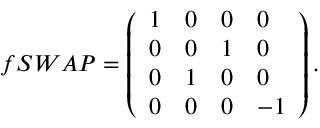Convert formula to latex. <formula><loc_0><loc_0><loc_500><loc_500>f S W A P = \left ( \begin{array} { l l l l } { 1 } & { 0 } & { 0 } & { 0 } \\ { 0 } & { 0 } & { 1 } & { 0 } \\ { 0 } & { 1 } & { 0 } & { 0 } \\ { 0 } & { 0 } & { 0 } & { - 1 } \end{array} \right ) .</formula> 